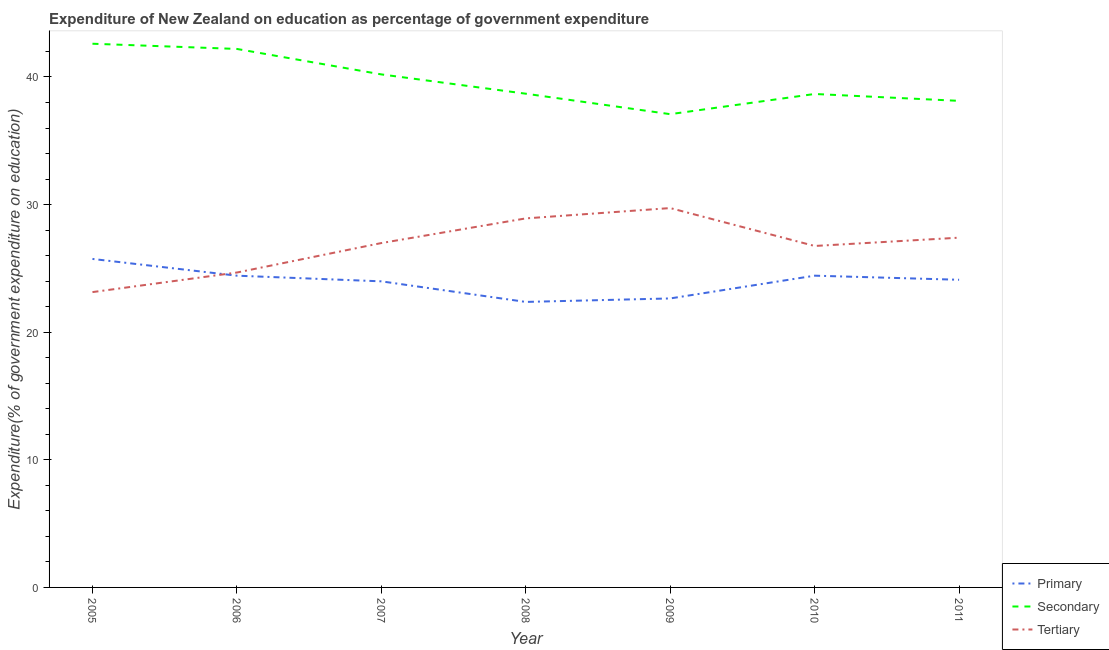How many different coloured lines are there?
Provide a succinct answer. 3. Does the line corresponding to expenditure on secondary education intersect with the line corresponding to expenditure on primary education?
Make the answer very short. No. Is the number of lines equal to the number of legend labels?
Provide a short and direct response. Yes. What is the expenditure on secondary education in 2006?
Your answer should be compact. 42.2. Across all years, what is the maximum expenditure on secondary education?
Provide a succinct answer. 42.61. Across all years, what is the minimum expenditure on primary education?
Ensure brevity in your answer.  22.37. What is the total expenditure on primary education in the graph?
Your answer should be very brief. 167.71. What is the difference between the expenditure on tertiary education in 2007 and that in 2010?
Offer a very short reply. 0.23. What is the difference between the expenditure on primary education in 2010 and the expenditure on secondary education in 2006?
Offer a terse response. -17.77. What is the average expenditure on secondary education per year?
Your answer should be very brief. 39.65. In the year 2006, what is the difference between the expenditure on secondary education and expenditure on tertiary education?
Keep it short and to the point. 17.52. In how many years, is the expenditure on primary education greater than 30 %?
Offer a very short reply. 0. What is the ratio of the expenditure on primary education in 2005 to that in 2010?
Provide a succinct answer. 1.05. Is the expenditure on tertiary education in 2007 less than that in 2009?
Provide a succinct answer. Yes. What is the difference between the highest and the second highest expenditure on primary education?
Provide a succinct answer. 1.31. What is the difference between the highest and the lowest expenditure on secondary education?
Keep it short and to the point. 5.52. In how many years, is the expenditure on primary education greater than the average expenditure on primary education taken over all years?
Provide a short and direct response. 5. Is the expenditure on tertiary education strictly less than the expenditure on secondary education over the years?
Keep it short and to the point. Yes. What is the difference between two consecutive major ticks on the Y-axis?
Give a very brief answer. 10. Are the values on the major ticks of Y-axis written in scientific E-notation?
Make the answer very short. No. How many legend labels are there?
Provide a succinct answer. 3. What is the title of the graph?
Make the answer very short. Expenditure of New Zealand on education as percentage of government expenditure. What is the label or title of the X-axis?
Offer a very short reply. Year. What is the label or title of the Y-axis?
Your answer should be compact. Expenditure(% of government expenditure on education). What is the Expenditure(% of government expenditure on education) in Primary in 2005?
Your answer should be compact. 25.74. What is the Expenditure(% of government expenditure on education) in Secondary in 2005?
Provide a short and direct response. 42.61. What is the Expenditure(% of government expenditure on education) in Tertiary in 2005?
Give a very brief answer. 23.14. What is the Expenditure(% of government expenditure on education) of Primary in 2006?
Offer a very short reply. 24.43. What is the Expenditure(% of government expenditure on education) in Secondary in 2006?
Your answer should be very brief. 42.2. What is the Expenditure(% of government expenditure on education) of Tertiary in 2006?
Offer a terse response. 24.68. What is the Expenditure(% of government expenditure on education) of Primary in 2007?
Your response must be concise. 23.99. What is the Expenditure(% of government expenditure on education) in Secondary in 2007?
Make the answer very short. 40.2. What is the Expenditure(% of government expenditure on education) in Tertiary in 2007?
Your answer should be compact. 26.99. What is the Expenditure(% of government expenditure on education) in Primary in 2008?
Your answer should be very brief. 22.37. What is the Expenditure(% of government expenditure on education) of Secondary in 2008?
Your response must be concise. 38.69. What is the Expenditure(% of government expenditure on education) in Tertiary in 2008?
Offer a terse response. 28.92. What is the Expenditure(% of government expenditure on education) of Primary in 2009?
Your answer should be compact. 22.65. What is the Expenditure(% of government expenditure on education) in Secondary in 2009?
Keep it short and to the point. 37.09. What is the Expenditure(% of government expenditure on education) of Tertiary in 2009?
Provide a short and direct response. 29.73. What is the Expenditure(% of government expenditure on education) of Primary in 2010?
Make the answer very short. 24.43. What is the Expenditure(% of government expenditure on education) of Secondary in 2010?
Ensure brevity in your answer.  38.67. What is the Expenditure(% of government expenditure on education) in Tertiary in 2010?
Offer a very short reply. 26.76. What is the Expenditure(% of government expenditure on education) of Primary in 2011?
Keep it short and to the point. 24.11. What is the Expenditure(% of government expenditure on education) in Secondary in 2011?
Give a very brief answer. 38.13. What is the Expenditure(% of government expenditure on education) in Tertiary in 2011?
Give a very brief answer. 27.41. Across all years, what is the maximum Expenditure(% of government expenditure on education) of Primary?
Offer a terse response. 25.74. Across all years, what is the maximum Expenditure(% of government expenditure on education) of Secondary?
Your answer should be compact. 42.61. Across all years, what is the maximum Expenditure(% of government expenditure on education) in Tertiary?
Make the answer very short. 29.73. Across all years, what is the minimum Expenditure(% of government expenditure on education) of Primary?
Offer a terse response. 22.37. Across all years, what is the minimum Expenditure(% of government expenditure on education) of Secondary?
Provide a short and direct response. 37.09. Across all years, what is the minimum Expenditure(% of government expenditure on education) of Tertiary?
Offer a terse response. 23.14. What is the total Expenditure(% of government expenditure on education) of Primary in the graph?
Your answer should be very brief. 167.71. What is the total Expenditure(% of government expenditure on education) in Secondary in the graph?
Your response must be concise. 277.58. What is the total Expenditure(% of government expenditure on education) in Tertiary in the graph?
Your answer should be very brief. 187.62. What is the difference between the Expenditure(% of government expenditure on education) of Primary in 2005 and that in 2006?
Your answer should be compact. 1.31. What is the difference between the Expenditure(% of government expenditure on education) of Secondary in 2005 and that in 2006?
Offer a very short reply. 0.41. What is the difference between the Expenditure(% of government expenditure on education) in Tertiary in 2005 and that in 2006?
Give a very brief answer. -1.53. What is the difference between the Expenditure(% of government expenditure on education) of Primary in 2005 and that in 2007?
Your answer should be compact. 1.76. What is the difference between the Expenditure(% of government expenditure on education) in Secondary in 2005 and that in 2007?
Provide a short and direct response. 2.4. What is the difference between the Expenditure(% of government expenditure on education) of Tertiary in 2005 and that in 2007?
Offer a terse response. -3.84. What is the difference between the Expenditure(% of government expenditure on education) in Primary in 2005 and that in 2008?
Make the answer very short. 3.37. What is the difference between the Expenditure(% of government expenditure on education) of Secondary in 2005 and that in 2008?
Offer a very short reply. 3.92. What is the difference between the Expenditure(% of government expenditure on education) in Tertiary in 2005 and that in 2008?
Give a very brief answer. -5.78. What is the difference between the Expenditure(% of government expenditure on education) of Primary in 2005 and that in 2009?
Make the answer very short. 3.1. What is the difference between the Expenditure(% of government expenditure on education) in Secondary in 2005 and that in 2009?
Ensure brevity in your answer.  5.52. What is the difference between the Expenditure(% of government expenditure on education) of Tertiary in 2005 and that in 2009?
Provide a short and direct response. -6.58. What is the difference between the Expenditure(% of government expenditure on education) of Primary in 2005 and that in 2010?
Offer a very short reply. 1.31. What is the difference between the Expenditure(% of government expenditure on education) in Secondary in 2005 and that in 2010?
Your answer should be compact. 3.94. What is the difference between the Expenditure(% of government expenditure on education) of Tertiary in 2005 and that in 2010?
Your answer should be compact. -3.61. What is the difference between the Expenditure(% of government expenditure on education) of Primary in 2005 and that in 2011?
Keep it short and to the point. 1.63. What is the difference between the Expenditure(% of government expenditure on education) in Secondary in 2005 and that in 2011?
Offer a very short reply. 4.48. What is the difference between the Expenditure(% of government expenditure on education) of Tertiary in 2005 and that in 2011?
Make the answer very short. -4.27. What is the difference between the Expenditure(% of government expenditure on education) of Primary in 2006 and that in 2007?
Give a very brief answer. 0.44. What is the difference between the Expenditure(% of government expenditure on education) in Secondary in 2006 and that in 2007?
Give a very brief answer. 2. What is the difference between the Expenditure(% of government expenditure on education) of Tertiary in 2006 and that in 2007?
Give a very brief answer. -2.31. What is the difference between the Expenditure(% of government expenditure on education) of Primary in 2006 and that in 2008?
Make the answer very short. 2.06. What is the difference between the Expenditure(% of government expenditure on education) of Secondary in 2006 and that in 2008?
Provide a succinct answer. 3.51. What is the difference between the Expenditure(% of government expenditure on education) in Tertiary in 2006 and that in 2008?
Give a very brief answer. -4.24. What is the difference between the Expenditure(% of government expenditure on education) in Primary in 2006 and that in 2009?
Your answer should be very brief. 1.78. What is the difference between the Expenditure(% of government expenditure on education) of Secondary in 2006 and that in 2009?
Your response must be concise. 5.11. What is the difference between the Expenditure(% of government expenditure on education) of Tertiary in 2006 and that in 2009?
Provide a short and direct response. -5.05. What is the difference between the Expenditure(% of government expenditure on education) in Primary in 2006 and that in 2010?
Provide a succinct answer. -0. What is the difference between the Expenditure(% of government expenditure on education) of Secondary in 2006 and that in 2010?
Your answer should be compact. 3.53. What is the difference between the Expenditure(% of government expenditure on education) in Tertiary in 2006 and that in 2010?
Your answer should be compact. -2.08. What is the difference between the Expenditure(% of government expenditure on education) in Primary in 2006 and that in 2011?
Provide a succinct answer. 0.32. What is the difference between the Expenditure(% of government expenditure on education) in Secondary in 2006 and that in 2011?
Keep it short and to the point. 4.07. What is the difference between the Expenditure(% of government expenditure on education) in Tertiary in 2006 and that in 2011?
Keep it short and to the point. -2.73. What is the difference between the Expenditure(% of government expenditure on education) in Primary in 2007 and that in 2008?
Offer a terse response. 1.61. What is the difference between the Expenditure(% of government expenditure on education) of Secondary in 2007 and that in 2008?
Provide a short and direct response. 1.51. What is the difference between the Expenditure(% of government expenditure on education) in Tertiary in 2007 and that in 2008?
Provide a short and direct response. -1.93. What is the difference between the Expenditure(% of government expenditure on education) in Primary in 2007 and that in 2009?
Your answer should be compact. 1.34. What is the difference between the Expenditure(% of government expenditure on education) of Secondary in 2007 and that in 2009?
Offer a terse response. 3.12. What is the difference between the Expenditure(% of government expenditure on education) of Tertiary in 2007 and that in 2009?
Give a very brief answer. -2.74. What is the difference between the Expenditure(% of government expenditure on education) in Primary in 2007 and that in 2010?
Give a very brief answer. -0.44. What is the difference between the Expenditure(% of government expenditure on education) in Secondary in 2007 and that in 2010?
Your answer should be very brief. 1.53. What is the difference between the Expenditure(% of government expenditure on education) of Tertiary in 2007 and that in 2010?
Offer a terse response. 0.23. What is the difference between the Expenditure(% of government expenditure on education) of Primary in 2007 and that in 2011?
Your answer should be very brief. -0.12. What is the difference between the Expenditure(% of government expenditure on education) in Secondary in 2007 and that in 2011?
Provide a succinct answer. 2.07. What is the difference between the Expenditure(% of government expenditure on education) of Tertiary in 2007 and that in 2011?
Make the answer very short. -0.42. What is the difference between the Expenditure(% of government expenditure on education) of Primary in 2008 and that in 2009?
Offer a terse response. -0.27. What is the difference between the Expenditure(% of government expenditure on education) in Secondary in 2008 and that in 2009?
Keep it short and to the point. 1.6. What is the difference between the Expenditure(% of government expenditure on education) in Tertiary in 2008 and that in 2009?
Offer a very short reply. -0.81. What is the difference between the Expenditure(% of government expenditure on education) of Primary in 2008 and that in 2010?
Provide a succinct answer. -2.06. What is the difference between the Expenditure(% of government expenditure on education) of Secondary in 2008 and that in 2010?
Ensure brevity in your answer.  0.02. What is the difference between the Expenditure(% of government expenditure on education) of Tertiary in 2008 and that in 2010?
Ensure brevity in your answer.  2.16. What is the difference between the Expenditure(% of government expenditure on education) in Primary in 2008 and that in 2011?
Your answer should be compact. -1.74. What is the difference between the Expenditure(% of government expenditure on education) in Secondary in 2008 and that in 2011?
Your response must be concise. 0.56. What is the difference between the Expenditure(% of government expenditure on education) in Tertiary in 2008 and that in 2011?
Your response must be concise. 1.51. What is the difference between the Expenditure(% of government expenditure on education) of Primary in 2009 and that in 2010?
Offer a very short reply. -1.78. What is the difference between the Expenditure(% of government expenditure on education) in Secondary in 2009 and that in 2010?
Your response must be concise. -1.58. What is the difference between the Expenditure(% of government expenditure on education) of Tertiary in 2009 and that in 2010?
Keep it short and to the point. 2.97. What is the difference between the Expenditure(% of government expenditure on education) in Primary in 2009 and that in 2011?
Keep it short and to the point. -1.46. What is the difference between the Expenditure(% of government expenditure on education) in Secondary in 2009 and that in 2011?
Offer a terse response. -1.04. What is the difference between the Expenditure(% of government expenditure on education) of Tertiary in 2009 and that in 2011?
Offer a very short reply. 2.32. What is the difference between the Expenditure(% of government expenditure on education) of Primary in 2010 and that in 2011?
Your response must be concise. 0.32. What is the difference between the Expenditure(% of government expenditure on education) in Secondary in 2010 and that in 2011?
Your answer should be very brief. 0.54. What is the difference between the Expenditure(% of government expenditure on education) of Tertiary in 2010 and that in 2011?
Offer a terse response. -0.65. What is the difference between the Expenditure(% of government expenditure on education) in Primary in 2005 and the Expenditure(% of government expenditure on education) in Secondary in 2006?
Keep it short and to the point. -16.46. What is the difference between the Expenditure(% of government expenditure on education) in Primary in 2005 and the Expenditure(% of government expenditure on education) in Tertiary in 2006?
Your response must be concise. 1.06. What is the difference between the Expenditure(% of government expenditure on education) in Secondary in 2005 and the Expenditure(% of government expenditure on education) in Tertiary in 2006?
Your response must be concise. 17.93. What is the difference between the Expenditure(% of government expenditure on education) of Primary in 2005 and the Expenditure(% of government expenditure on education) of Secondary in 2007?
Provide a succinct answer. -14.46. What is the difference between the Expenditure(% of government expenditure on education) in Primary in 2005 and the Expenditure(% of government expenditure on education) in Tertiary in 2007?
Ensure brevity in your answer.  -1.24. What is the difference between the Expenditure(% of government expenditure on education) of Secondary in 2005 and the Expenditure(% of government expenditure on education) of Tertiary in 2007?
Your response must be concise. 15.62. What is the difference between the Expenditure(% of government expenditure on education) in Primary in 2005 and the Expenditure(% of government expenditure on education) in Secondary in 2008?
Ensure brevity in your answer.  -12.95. What is the difference between the Expenditure(% of government expenditure on education) of Primary in 2005 and the Expenditure(% of government expenditure on education) of Tertiary in 2008?
Keep it short and to the point. -3.18. What is the difference between the Expenditure(% of government expenditure on education) of Secondary in 2005 and the Expenditure(% of government expenditure on education) of Tertiary in 2008?
Keep it short and to the point. 13.69. What is the difference between the Expenditure(% of government expenditure on education) of Primary in 2005 and the Expenditure(% of government expenditure on education) of Secondary in 2009?
Your answer should be compact. -11.34. What is the difference between the Expenditure(% of government expenditure on education) of Primary in 2005 and the Expenditure(% of government expenditure on education) of Tertiary in 2009?
Your answer should be very brief. -3.99. What is the difference between the Expenditure(% of government expenditure on education) of Secondary in 2005 and the Expenditure(% of government expenditure on education) of Tertiary in 2009?
Provide a succinct answer. 12.88. What is the difference between the Expenditure(% of government expenditure on education) of Primary in 2005 and the Expenditure(% of government expenditure on education) of Secondary in 2010?
Keep it short and to the point. -12.93. What is the difference between the Expenditure(% of government expenditure on education) in Primary in 2005 and the Expenditure(% of government expenditure on education) in Tertiary in 2010?
Your answer should be very brief. -1.02. What is the difference between the Expenditure(% of government expenditure on education) of Secondary in 2005 and the Expenditure(% of government expenditure on education) of Tertiary in 2010?
Your answer should be compact. 15.85. What is the difference between the Expenditure(% of government expenditure on education) of Primary in 2005 and the Expenditure(% of government expenditure on education) of Secondary in 2011?
Offer a very short reply. -12.39. What is the difference between the Expenditure(% of government expenditure on education) in Primary in 2005 and the Expenditure(% of government expenditure on education) in Tertiary in 2011?
Offer a terse response. -1.67. What is the difference between the Expenditure(% of government expenditure on education) of Secondary in 2005 and the Expenditure(% of government expenditure on education) of Tertiary in 2011?
Give a very brief answer. 15.2. What is the difference between the Expenditure(% of government expenditure on education) of Primary in 2006 and the Expenditure(% of government expenditure on education) of Secondary in 2007?
Ensure brevity in your answer.  -15.77. What is the difference between the Expenditure(% of government expenditure on education) in Primary in 2006 and the Expenditure(% of government expenditure on education) in Tertiary in 2007?
Keep it short and to the point. -2.56. What is the difference between the Expenditure(% of government expenditure on education) in Secondary in 2006 and the Expenditure(% of government expenditure on education) in Tertiary in 2007?
Your answer should be very brief. 15.21. What is the difference between the Expenditure(% of government expenditure on education) in Primary in 2006 and the Expenditure(% of government expenditure on education) in Secondary in 2008?
Make the answer very short. -14.26. What is the difference between the Expenditure(% of government expenditure on education) in Primary in 2006 and the Expenditure(% of government expenditure on education) in Tertiary in 2008?
Your answer should be compact. -4.49. What is the difference between the Expenditure(% of government expenditure on education) in Secondary in 2006 and the Expenditure(% of government expenditure on education) in Tertiary in 2008?
Offer a terse response. 13.28. What is the difference between the Expenditure(% of government expenditure on education) in Primary in 2006 and the Expenditure(% of government expenditure on education) in Secondary in 2009?
Ensure brevity in your answer.  -12.66. What is the difference between the Expenditure(% of government expenditure on education) in Primary in 2006 and the Expenditure(% of government expenditure on education) in Tertiary in 2009?
Ensure brevity in your answer.  -5.3. What is the difference between the Expenditure(% of government expenditure on education) in Secondary in 2006 and the Expenditure(% of government expenditure on education) in Tertiary in 2009?
Keep it short and to the point. 12.47. What is the difference between the Expenditure(% of government expenditure on education) of Primary in 2006 and the Expenditure(% of government expenditure on education) of Secondary in 2010?
Keep it short and to the point. -14.24. What is the difference between the Expenditure(% of government expenditure on education) of Primary in 2006 and the Expenditure(% of government expenditure on education) of Tertiary in 2010?
Your answer should be compact. -2.33. What is the difference between the Expenditure(% of government expenditure on education) of Secondary in 2006 and the Expenditure(% of government expenditure on education) of Tertiary in 2010?
Your answer should be very brief. 15.44. What is the difference between the Expenditure(% of government expenditure on education) of Primary in 2006 and the Expenditure(% of government expenditure on education) of Secondary in 2011?
Keep it short and to the point. -13.7. What is the difference between the Expenditure(% of government expenditure on education) in Primary in 2006 and the Expenditure(% of government expenditure on education) in Tertiary in 2011?
Your response must be concise. -2.98. What is the difference between the Expenditure(% of government expenditure on education) in Secondary in 2006 and the Expenditure(% of government expenditure on education) in Tertiary in 2011?
Provide a succinct answer. 14.79. What is the difference between the Expenditure(% of government expenditure on education) in Primary in 2007 and the Expenditure(% of government expenditure on education) in Secondary in 2008?
Provide a succinct answer. -14.7. What is the difference between the Expenditure(% of government expenditure on education) in Primary in 2007 and the Expenditure(% of government expenditure on education) in Tertiary in 2008?
Provide a succinct answer. -4.93. What is the difference between the Expenditure(% of government expenditure on education) in Secondary in 2007 and the Expenditure(% of government expenditure on education) in Tertiary in 2008?
Offer a very short reply. 11.28. What is the difference between the Expenditure(% of government expenditure on education) of Primary in 2007 and the Expenditure(% of government expenditure on education) of Secondary in 2009?
Give a very brief answer. -13.1. What is the difference between the Expenditure(% of government expenditure on education) of Primary in 2007 and the Expenditure(% of government expenditure on education) of Tertiary in 2009?
Your response must be concise. -5.74. What is the difference between the Expenditure(% of government expenditure on education) in Secondary in 2007 and the Expenditure(% of government expenditure on education) in Tertiary in 2009?
Provide a short and direct response. 10.47. What is the difference between the Expenditure(% of government expenditure on education) in Primary in 2007 and the Expenditure(% of government expenditure on education) in Secondary in 2010?
Make the answer very short. -14.68. What is the difference between the Expenditure(% of government expenditure on education) in Primary in 2007 and the Expenditure(% of government expenditure on education) in Tertiary in 2010?
Your answer should be very brief. -2.77. What is the difference between the Expenditure(% of government expenditure on education) in Secondary in 2007 and the Expenditure(% of government expenditure on education) in Tertiary in 2010?
Provide a succinct answer. 13.44. What is the difference between the Expenditure(% of government expenditure on education) of Primary in 2007 and the Expenditure(% of government expenditure on education) of Secondary in 2011?
Ensure brevity in your answer.  -14.14. What is the difference between the Expenditure(% of government expenditure on education) of Primary in 2007 and the Expenditure(% of government expenditure on education) of Tertiary in 2011?
Give a very brief answer. -3.42. What is the difference between the Expenditure(% of government expenditure on education) in Secondary in 2007 and the Expenditure(% of government expenditure on education) in Tertiary in 2011?
Your answer should be very brief. 12.79. What is the difference between the Expenditure(% of government expenditure on education) of Primary in 2008 and the Expenditure(% of government expenditure on education) of Secondary in 2009?
Ensure brevity in your answer.  -14.71. What is the difference between the Expenditure(% of government expenditure on education) in Primary in 2008 and the Expenditure(% of government expenditure on education) in Tertiary in 2009?
Keep it short and to the point. -7.35. What is the difference between the Expenditure(% of government expenditure on education) of Secondary in 2008 and the Expenditure(% of government expenditure on education) of Tertiary in 2009?
Provide a succinct answer. 8.96. What is the difference between the Expenditure(% of government expenditure on education) of Primary in 2008 and the Expenditure(% of government expenditure on education) of Secondary in 2010?
Offer a very short reply. -16.3. What is the difference between the Expenditure(% of government expenditure on education) in Primary in 2008 and the Expenditure(% of government expenditure on education) in Tertiary in 2010?
Make the answer very short. -4.38. What is the difference between the Expenditure(% of government expenditure on education) of Secondary in 2008 and the Expenditure(% of government expenditure on education) of Tertiary in 2010?
Your answer should be compact. 11.93. What is the difference between the Expenditure(% of government expenditure on education) of Primary in 2008 and the Expenditure(% of government expenditure on education) of Secondary in 2011?
Offer a very short reply. -15.76. What is the difference between the Expenditure(% of government expenditure on education) of Primary in 2008 and the Expenditure(% of government expenditure on education) of Tertiary in 2011?
Your response must be concise. -5.04. What is the difference between the Expenditure(% of government expenditure on education) in Secondary in 2008 and the Expenditure(% of government expenditure on education) in Tertiary in 2011?
Offer a terse response. 11.28. What is the difference between the Expenditure(% of government expenditure on education) of Primary in 2009 and the Expenditure(% of government expenditure on education) of Secondary in 2010?
Provide a short and direct response. -16.02. What is the difference between the Expenditure(% of government expenditure on education) in Primary in 2009 and the Expenditure(% of government expenditure on education) in Tertiary in 2010?
Your answer should be compact. -4.11. What is the difference between the Expenditure(% of government expenditure on education) of Secondary in 2009 and the Expenditure(% of government expenditure on education) of Tertiary in 2010?
Give a very brief answer. 10.33. What is the difference between the Expenditure(% of government expenditure on education) in Primary in 2009 and the Expenditure(% of government expenditure on education) in Secondary in 2011?
Your answer should be very brief. -15.48. What is the difference between the Expenditure(% of government expenditure on education) in Primary in 2009 and the Expenditure(% of government expenditure on education) in Tertiary in 2011?
Provide a short and direct response. -4.76. What is the difference between the Expenditure(% of government expenditure on education) in Secondary in 2009 and the Expenditure(% of government expenditure on education) in Tertiary in 2011?
Keep it short and to the point. 9.68. What is the difference between the Expenditure(% of government expenditure on education) of Primary in 2010 and the Expenditure(% of government expenditure on education) of Secondary in 2011?
Keep it short and to the point. -13.7. What is the difference between the Expenditure(% of government expenditure on education) in Primary in 2010 and the Expenditure(% of government expenditure on education) in Tertiary in 2011?
Keep it short and to the point. -2.98. What is the difference between the Expenditure(% of government expenditure on education) of Secondary in 2010 and the Expenditure(% of government expenditure on education) of Tertiary in 2011?
Your answer should be very brief. 11.26. What is the average Expenditure(% of government expenditure on education) of Primary per year?
Your answer should be compact. 23.96. What is the average Expenditure(% of government expenditure on education) of Secondary per year?
Provide a short and direct response. 39.65. What is the average Expenditure(% of government expenditure on education) in Tertiary per year?
Offer a very short reply. 26.8. In the year 2005, what is the difference between the Expenditure(% of government expenditure on education) in Primary and Expenditure(% of government expenditure on education) in Secondary?
Your response must be concise. -16.86. In the year 2005, what is the difference between the Expenditure(% of government expenditure on education) of Primary and Expenditure(% of government expenditure on education) of Tertiary?
Provide a short and direct response. 2.6. In the year 2005, what is the difference between the Expenditure(% of government expenditure on education) of Secondary and Expenditure(% of government expenditure on education) of Tertiary?
Provide a succinct answer. 19.46. In the year 2006, what is the difference between the Expenditure(% of government expenditure on education) in Primary and Expenditure(% of government expenditure on education) in Secondary?
Provide a succinct answer. -17.77. In the year 2006, what is the difference between the Expenditure(% of government expenditure on education) in Primary and Expenditure(% of government expenditure on education) in Tertiary?
Offer a terse response. -0.25. In the year 2006, what is the difference between the Expenditure(% of government expenditure on education) of Secondary and Expenditure(% of government expenditure on education) of Tertiary?
Your answer should be very brief. 17.52. In the year 2007, what is the difference between the Expenditure(% of government expenditure on education) of Primary and Expenditure(% of government expenditure on education) of Secondary?
Offer a terse response. -16.22. In the year 2007, what is the difference between the Expenditure(% of government expenditure on education) in Secondary and Expenditure(% of government expenditure on education) in Tertiary?
Ensure brevity in your answer.  13.22. In the year 2008, what is the difference between the Expenditure(% of government expenditure on education) in Primary and Expenditure(% of government expenditure on education) in Secondary?
Give a very brief answer. -16.32. In the year 2008, what is the difference between the Expenditure(% of government expenditure on education) in Primary and Expenditure(% of government expenditure on education) in Tertiary?
Give a very brief answer. -6.54. In the year 2008, what is the difference between the Expenditure(% of government expenditure on education) in Secondary and Expenditure(% of government expenditure on education) in Tertiary?
Ensure brevity in your answer.  9.77. In the year 2009, what is the difference between the Expenditure(% of government expenditure on education) of Primary and Expenditure(% of government expenditure on education) of Secondary?
Offer a very short reply. -14.44. In the year 2009, what is the difference between the Expenditure(% of government expenditure on education) of Primary and Expenditure(% of government expenditure on education) of Tertiary?
Offer a very short reply. -7.08. In the year 2009, what is the difference between the Expenditure(% of government expenditure on education) of Secondary and Expenditure(% of government expenditure on education) of Tertiary?
Your response must be concise. 7.36. In the year 2010, what is the difference between the Expenditure(% of government expenditure on education) in Primary and Expenditure(% of government expenditure on education) in Secondary?
Give a very brief answer. -14.24. In the year 2010, what is the difference between the Expenditure(% of government expenditure on education) of Primary and Expenditure(% of government expenditure on education) of Tertiary?
Make the answer very short. -2.33. In the year 2010, what is the difference between the Expenditure(% of government expenditure on education) of Secondary and Expenditure(% of government expenditure on education) of Tertiary?
Your answer should be compact. 11.91. In the year 2011, what is the difference between the Expenditure(% of government expenditure on education) of Primary and Expenditure(% of government expenditure on education) of Secondary?
Offer a very short reply. -14.02. In the year 2011, what is the difference between the Expenditure(% of government expenditure on education) of Primary and Expenditure(% of government expenditure on education) of Tertiary?
Provide a succinct answer. -3.3. In the year 2011, what is the difference between the Expenditure(% of government expenditure on education) of Secondary and Expenditure(% of government expenditure on education) of Tertiary?
Ensure brevity in your answer.  10.72. What is the ratio of the Expenditure(% of government expenditure on education) of Primary in 2005 to that in 2006?
Give a very brief answer. 1.05. What is the ratio of the Expenditure(% of government expenditure on education) in Secondary in 2005 to that in 2006?
Your response must be concise. 1.01. What is the ratio of the Expenditure(% of government expenditure on education) of Tertiary in 2005 to that in 2006?
Your answer should be very brief. 0.94. What is the ratio of the Expenditure(% of government expenditure on education) in Primary in 2005 to that in 2007?
Make the answer very short. 1.07. What is the ratio of the Expenditure(% of government expenditure on education) in Secondary in 2005 to that in 2007?
Offer a terse response. 1.06. What is the ratio of the Expenditure(% of government expenditure on education) in Tertiary in 2005 to that in 2007?
Ensure brevity in your answer.  0.86. What is the ratio of the Expenditure(% of government expenditure on education) in Primary in 2005 to that in 2008?
Ensure brevity in your answer.  1.15. What is the ratio of the Expenditure(% of government expenditure on education) in Secondary in 2005 to that in 2008?
Provide a succinct answer. 1.1. What is the ratio of the Expenditure(% of government expenditure on education) of Tertiary in 2005 to that in 2008?
Offer a very short reply. 0.8. What is the ratio of the Expenditure(% of government expenditure on education) in Primary in 2005 to that in 2009?
Your answer should be compact. 1.14. What is the ratio of the Expenditure(% of government expenditure on education) in Secondary in 2005 to that in 2009?
Give a very brief answer. 1.15. What is the ratio of the Expenditure(% of government expenditure on education) of Tertiary in 2005 to that in 2009?
Keep it short and to the point. 0.78. What is the ratio of the Expenditure(% of government expenditure on education) of Primary in 2005 to that in 2010?
Keep it short and to the point. 1.05. What is the ratio of the Expenditure(% of government expenditure on education) in Secondary in 2005 to that in 2010?
Keep it short and to the point. 1.1. What is the ratio of the Expenditure(% of government expenditure on education) in Tertiary in 2005 to that in 2010?
Keep it short and to the point. 0.86. What is the ratio of the Expenditure(% of government expenditure on education) of Primary in 2005 to that in 2011?
Keep it short and to the point. 1.07. What is the ratio of the Expenditure(% of government expenditure on education) of Secondary in 2005 to that in 2011?
Your answer should be very brief. 1.12. What is the ratio of the Expenditure(% of government expenditure on education) of Tertiary in 2005 to that in 2011?
Your response must be concise. 0.84. What is the ratio of the Expenditure(% of government expenditure on education) in Primary in 2006 to that in 2007?
Provide a short and direct response. 1.02. What is the ratio of the Expenditure(% of government expenditure on education) of Secondary in 2006 to that in 2007?
Your answer should be compact. 1.05. What is the ratio of the Expenditure(% of government expenditure on education) in Tertiary in 2006 to that in 2007?
Offer a very short reply. 0.91. What is the ratio of the Expenditure(% of government expenditure on education) in Primary in 2006 to that in 2008?
Your response must be concise. 1.09. What is the ratio of the Expenditure(% of government expenditure on education) in Secondary in 2006 to that in 2008?
Your response must be concise. 1.09. What is the ratio of the Expenditure(% of government expenditure on education) of Tertiary in 2006 to that in 2008?
Ensure brevity in your answer.  0.85. What is the ratio of the Expenditure(% of government expenditure on education) of Primary in 2006 to that in 2009?
Provide a succinct answer. 1.08. What is the ratio of the Expenditure(% of government expenditure on education) of Secondary in 2006 to that in 2009?
Offer a terse response. 1.14. What is the ratio of the Expenditure(% of government expenditure on education) of Tertiary in 2006 to that in 2009?
Offer a very short reply. 0.83. What is the ratio of the Expenditure(% of government expenditure on education) in Primary in 2006 to that in 2010?
Provide a succinct answer. 1. What is the ratio of the Expenditure(% of government expenditure on education) in Secondary in 2006 to that in 2010?
Your response must be concise. 1.09. What is the ratio of the Expenditure(% of government expenditure on education) in Tertiary in 2006 to that in 2010?
Provide a succinct answer. 0.92. What is the ratio of the Expenditure(% of government expenditure on education) in Primary in 2006 to that in 2011?
Provide a short and direct response. 1.01. What is the ratio of the Expenditure(% of government expenditure on education) of Secondary in 2006 to that in 2011?
Provide a succinct answer. 1.11. What is the ratio of the Expenditure(% of government expenditure on education) in Tertiary in 2006 to that in 2011?
Offer a very short reply. 0.9. What is the ratio of the Expenditure(% of government expenditure on education) of Primary in 2007 to that in 2008?
Make the answer very short. 1.07. What is the ratio of the Expenditure(% of government expenditure on education) in Secondary in 2007 to that in 2008?
Offer a very short reply. 1.04. What is the ratio of the Expenditure(% of government expenditure on education) of Tertiary in 2007 to that in 2008?
Your response must be concise. 0.93. What is the ratio of the Expenditure(% of government expenditure on education) in Primary in 2007 to that in 2009?
Your answer should be compact. 1.06. What is the ratio of the Expenditure(% of government expenditure on education) of Secondary in 2007 to that in 2009?
Your answer should be very brief. 1.08. What is the ratio of the Expenditure(% of government expenditure on education) in Tertiary in 2007 to that in 2009?
Give a very brief answer. 0.91. What is the ratio of the Expenditure(% of government expenditure on education) of Primary in 2007 to that in 2010?
Your answer should be very brief. 0.98. What is the ratio of the Expenditure(% of government expenditure on education) of Secondary in 2007 to that in 2010?
Your answer should be very brief. 1.04. What is the ratio of the Expenditure(% of government expenditure on education) of Tertiary in 2007 to that in 2010?
Provide a succinct answer. 1.01. What is the ratio of the Expenditure(% of government expenditure on education) of Secondary in 2007 to that in 2011?
Offer a terse response. 1.05. What is the ratio of the Expenditure(% of government expenditure on education) in Tertiary in 2007 to that in 2011?
Your answer should be very brief. 0.98. What is the ratio of the Expenditure(% of government expenditure on education) in Primary in 2008 to that in 2009?
Provide a short and direct response. 0.99. What is the ratio of the Expenditure(% of government expenditure on education) in Secondary in 2008 to that in 2009?
Your answer should be very brief. 1.04. What is the ratio of the Expenditure(% of government expenditure on education) in Tertiary in 2008 to that in 2009?
Provide a succinct answer. 0.97. What is the ratio of the Expenditure(% of government expenditure on education) of Primary in 2008 to that in 2010?
Your response must be concise. 0.92. What is the ratio of the Expenditure(% of government expenditure on education) in Tertiary in 2008 to that in 2010?
Ensure brevity in your answer.  1.08. What is the ratio of the Expenditure(% of government expenditure on education) of Primary in 2008 to that in 2011?
Make the answer very short. 0.93. What is the ratio of the Expenditure(% of government expenditure on education) in Secondary in 2008 to that in 2011?
Keep it short and to the point. 1.01. What is the ratio of the Expenditure(% of government expenditure on education) of Tertiary in 2008 to that in 2011?
Your answer should be very brief. 1.06. What is the ratio of the Expenditure(% of government expenditure on education) of Primary in 2009 to that in 2010?
Your response must be concise. 0.93. What is the ratio of the Expenditure(% of government expenditure on education) in Secondary in 2009 to that in 2010?
Give a very brief answer. 0.96. What is the ratio of the Expenditure(% of government expenditure on education) of Tertiary in 2009 to that in 2010?
Your response must be concise. 1.11. What is the ratio of the Expenditure(% of government expenditure on education) in Primary in 2009 to that in 2011?
Ensure brevity in your answer.  0.94. What is the ratio of the Expenditure(% of government expenditure on education) of Secondary in 2009 to that in 2011?
Your answer should be compact. 0.97. What is the ratio of the Expenditure(% of government expenditure on education) of Tertiary in 2009 to that in 2011?
Give a very brief answer. 1.08. What is the ratio of the Expenditure(% of government expenditure on education) in Primary in 2010 to that in 2011?
Your answer should be very brief. 1.01. What is the ratio of the Expenditure(% of government expenditure on education) in Secondary in 2010 to that in 2011?
Give a very brief answer. 1.01. What is the ratio of the Expenditure(% of government expenditure on education) in Tertiary in 2010 to that in 2011?
Your answer should be compact. 0.98. What is the difference between the highest and the second highest Expenditure(% of government expenditure on education) in Primary?
Your answer should be compact. 1.31. What is the difference between the highest and the second highest Expenditure(% of government expenditure on education) of Secondary?
Offer a very short reply. 0.41. What is the difference between the highest and the second highest Expenditure(% of government expenditure on education) of Tertiary?
Keep it short and to the point. 0.81. What is the difference between the highest and the lowest Expenditure(% of government expenditure on education) of Primary?
Your answer should be compact. 3.37. What is the difference between the highest and the lowest Expenditure(% of government expenditure on education) of Secondary?
Your answer should be compact. 5.52. What is the difference between the highest and the lowest Expenditure(% of government expenditure on education) in Tertiary?
Your answer should be very brief. 6.58. 